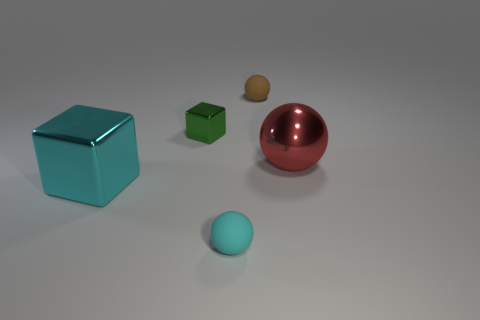Add 3 cyan balls. How many objects exist? 8 Subtract all cubes. How many objects are left? 3 Add 1 small cyan things. How many small cyan things exist? 2 Subtract 0 purple cubes. How many objects are left? 5 Subtract all red metal objects. Subtract all large shiny blocks. How many objects are left? 3 Add 3 small brown rubber balls. How many small brown rubber balls are left? 4 